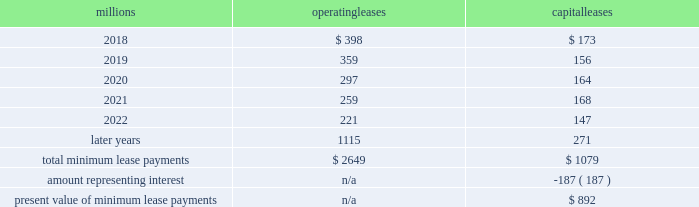17 .
Leases we lease certain locomotives , freight cars , and other property .
The consolidated statements of financial position as of december 31 , 2017 , and 2016 included $ 1635 million , net of $ 953 million of accumulated depreciation , and $ 1997 million , net of $ 1121 million of accumulated depreciation , respectively , for properties held under capital leases .
A charge to income resulting from the depreciation for assets held under capital leases is included within depreciation expense in our consolidated statements of income .
Future minimum lease payments for operating and capital leases with initial or remaining non-cancelable lease terms in excess of one year as of december 31 , 2017 , were as follows : millions operating leases capital leases .
Approximately 97% ( 97 % ) of capital lease payments relate to locomotives .
Rent expense for operating leases with terms exceeding one month was $ 480 million in 2017 , $ 535 million in 2016 , and $ 590 million in 2015 .
When cash rental payments are not made on a straight-line basis , we recognize variable rental expense on a straight-line basis over the lease term .
Contingent rentals and sub-rentals are not significant .
18 .
Commitments and contingencies asserted and unasserted claims 2013 various claims and lawsuits are pending against us and certain of our subsidiaries .
We cannot fully determine the effect of all asserted and unasserted claims on our consolidated results of operations , financial condition , or liquidity .
To the extent possible , we have recorded a liability where asserted and unasserted claims are considered probable and where such claims can be reasonably estimated .
We do not expect that any known lawsuits , claims , environmental costs , commitments , contingent liabilities , or guarantees will have a material adverse effect on our consolidated results of operations , financial condition , or liquidity after taking into account liabilities and insurance recoveries previously recorded for these matters .
Personal injury 2013 the cost of personal injuries to employees and others related to our activities is charged to expense based on estimates of the ultimate cost and number of incidents each year .
We use an actuarial analysis to measure the expense and liability , including unasserted claims .
The federal employers 2019 liability act ( fela ) governs compensation for work-related accidents .
Under fela , damages are assessed based on a finding of fault through litigation or out-of-court settlements .
We offer a comprehensive variety of services and rehabilitation programs for employees who are injured at work .
Our personal injury liability is not discounted to present value due to the uncertainty surrounding the timing of future payments .
Approximately 95% ( 95 % ) of the recorded liability is related to asserted claims and approximately 5% ( 5 % ) is related to unasserted claims at december 31 , 2017 .
Because of the uncertainty surrounding the ultimate outcome of personal injury claims , it is reasonably possible that future costs to settle these claims may range from approximately $ 285 million to $ 310 million .
We record an accrual at the low end of the range as no amount of loss within the range is more probable than any other .
Estimates can vary over time due to evolving trends in litigation. .
What percentage of total minimum lease payments are capital leases? 
Computations: (1079 / (2649 + 1079))
Answer: 0.28943. 